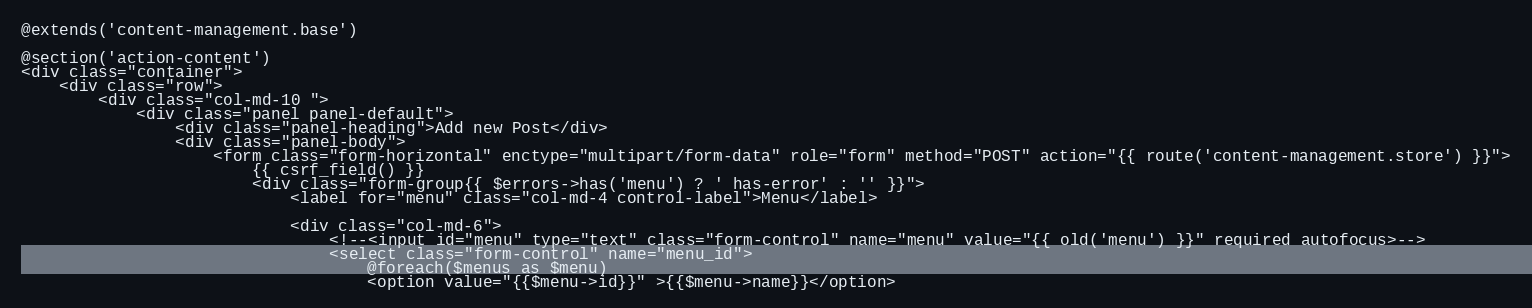Convert code to text. <code><loc_0><loc_0><loc_500><loc_500><_PHP_>@extends('content-management.base')

@section('action-content')
<div class="container">
    <div class="row">
        <div class="col-md-10 ">
            <div class="panel panel-default">
                <div class="panel-heading">Add new Post</div>
                <div class="panel-body">
                    <form class="form-horizontal" enctype="multipart/form-data" role="form" method="POST" action="{{ route('content-management.store') }}">
                        {{ csrf_field() }}
                        <div class="form-group{{ $errors->has('menu') ? ' has-error' : '' }}">
                            <label for="menu" class="col-md-4 control-label">Menu</label>

                            <div class="col-md-6">
                                <!--<input id="menu" type="text" class="form-control" name="menu" value="{{ old('menu') }}" required autofocus>-->
                                <select class="form-control" name="menu_id">
                                    @foreach($menus as $menu)
                                    <option value="{{$menu->id}}" >{{$menu->name}}</option></code> 